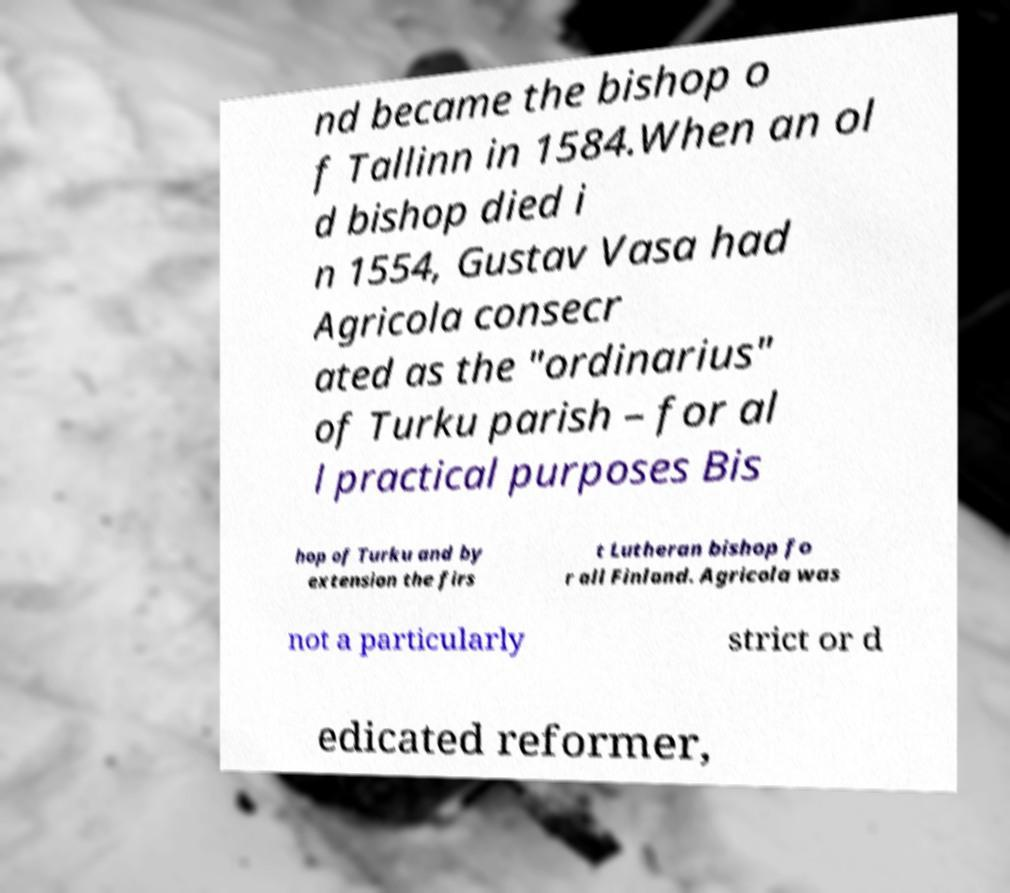There's text embedded in this image that I need extracted. Can you transcribe it verbatim? nd became the bishop o f Tallinn in 1584.When an ol d bishop died i n 1554, Gustav Vasa had Agricola consecr ated as the "ordinarius" of Turku parish – for al l practical purposes Bis hop of Turku and by extension the firs t Lutheran bishop fo r all Finland. Agricola was not a particularly strict or d edicated reformer, 